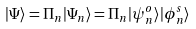Convert formula to latex. <formula><loc_0><loc_0><loc_500><loc_500>| \Psi \rangle = \Pi _ { n } | \Psi _ { n } \rangle = \Pi _ { n } | \psi ^ { o } _ { n } \rangle | \phi ^ { s } _ { n } \rangle</formula> 